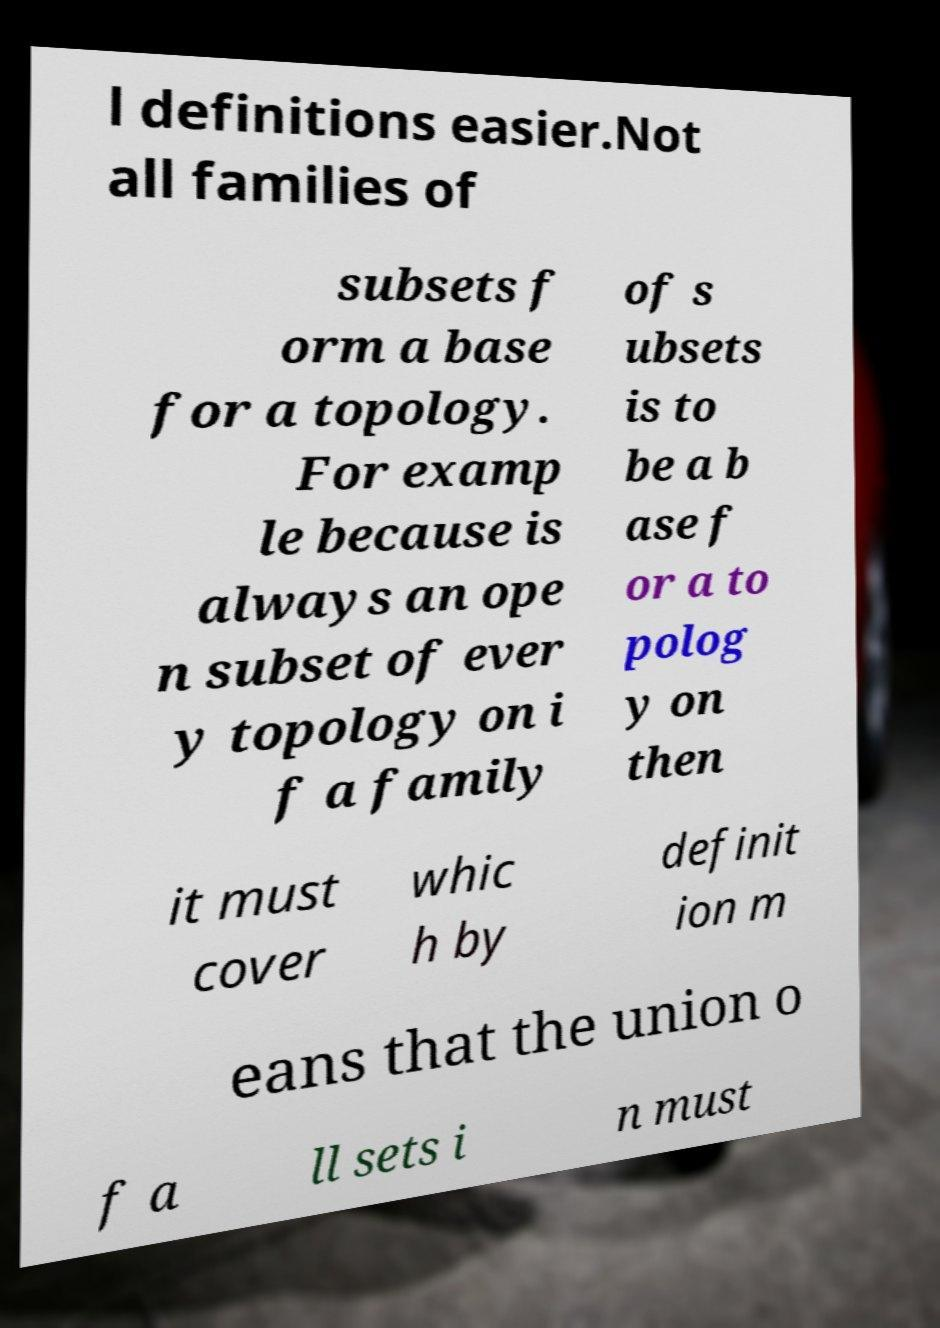What messages or text are displayed in this image? I need them in a readable, typed format. l definitions easier.Not all families of subsets f orm a base for a topology. For examp le because is always an ope n subset of ever y topology on i f a family of s ubsets is to be a b ase f or a to polog y on then it must cover whic h by definit ion m eans that the union o f a ll sets i n must 